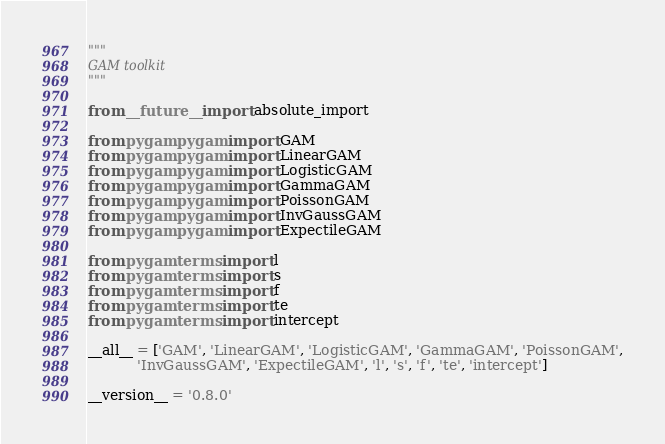Convert code to text. <code><loc_0><loc_0><loc_500><loc_500><_Python_>"""
GAM toolkit
"""

from __future__ import absolute_import

from pygam.pygam import GAM
from pygam.pygam import LinearGAM
from pygam.pygam import LogisticGAM
from pygam.pygam import GammaGAM
from pygam.pygam import PoissonGAM
from pygam.pygam import InvGaussGAM
from pygam.pygam import ExpectileGAM

from pygam.terms import l
from pygam.terms import s
from pygam.terms import f
from pygam.terms import te
from pygam.terms import intercept

__all__ = ['GAM', 'LinearGAM', 'LogisticGAM', 'GammaGAM', 'PoissonGAM',
           'InvGaussGAM', 'ExpectileGAM', 'l', 's', 'f', 'te', 'intercept']

__version__ = '0.8.0'
</code> 